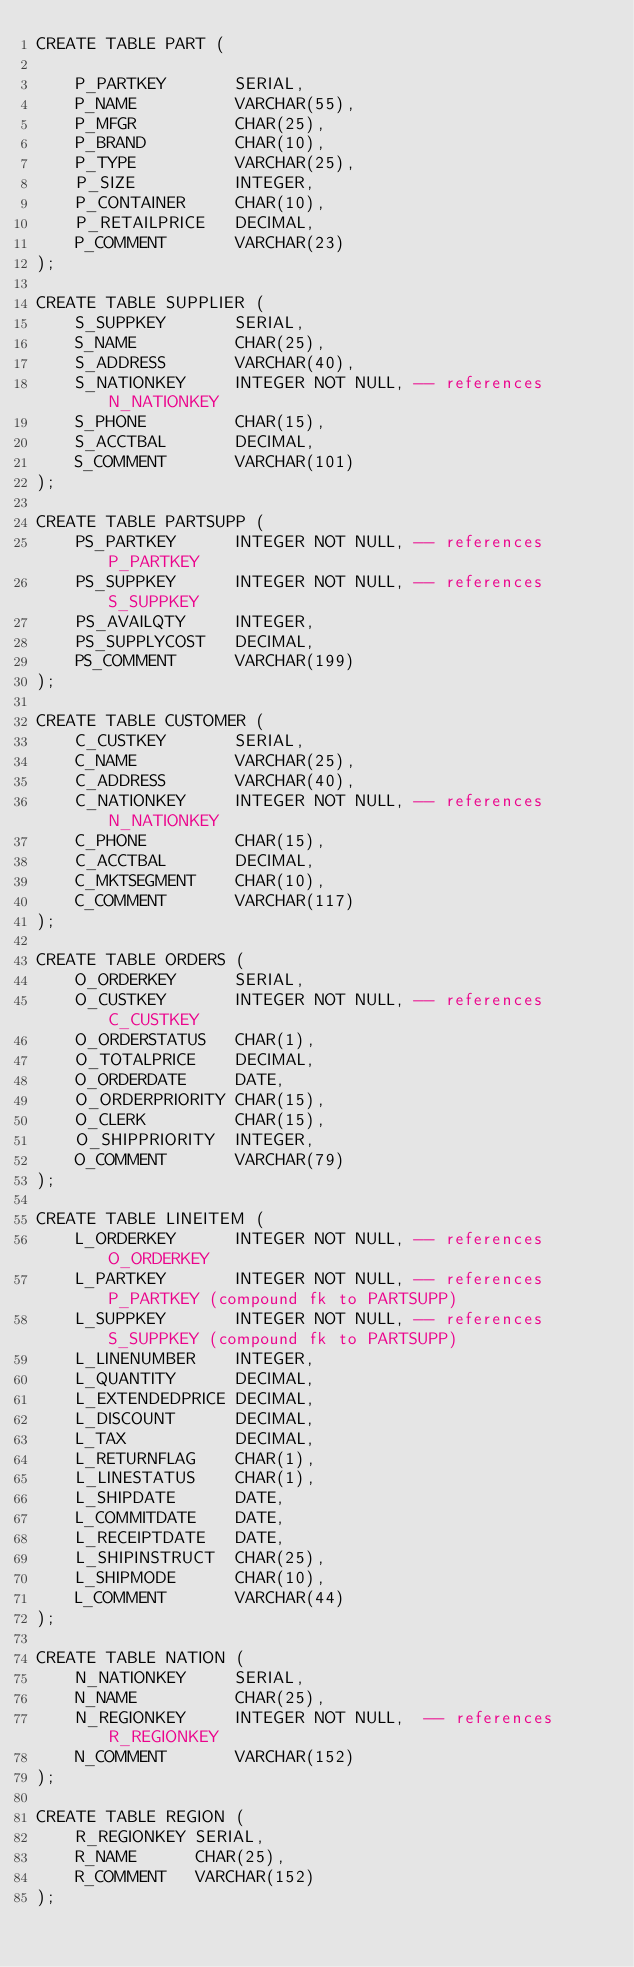Convert code to text. <code><loc_0><loc_0><loc_500><loc_500><_SQL_>CREATE TABLE PART (

	P_PARTKEY		SERIAL,
	P_NAME			VARCHAR(55),
	P_MFGR			CHAR(25),
	P_BRAND			CHAR(10),
	P_TYPE			VARCHAR(25),
	P_SIZE			INTEGER,
	P_CONTAINER		CHAR(10),
	P_RETAILPRICE	DECIMAL,
	P_COMMENT		VARCHAR(23)
);

CREATE TABLE SUPPLIER (
	S_SUPPKEY		SERIAL,
	S_NAME			CHAR(25),
	S_ADDRESS		VARCHAR(40),
	S_NATIONKEY		INTEGER NOT NULL, -- references N_NATIONKEY
	S_PHONE			CHAR(15),
	S_ACCTBAL		DECIMAL,
	S_COMMENT		VARCHAR(101)
);

CREATE TABLE PARTSUPP (
	PS_PARTKEY		INTEGER NOT NULL, -- references P_PARTKEY
	PS_SUPPKEY		INTEGER NOT NULL, -- references S_SUPPKEY
	PS_AVAILQTY		INTEGER,
	PS_SUPPLYCOST	DECIMAL,
	PS_COMMENT		VARCHAR(199)
);

CREATE TABLE CUSTOMER (
	C_CUSTKEY		SERIAL,
	C_NAME			VARCHAR(25),
	C_ADDRESS		VARCHAR(40),
	C_NATIONKEY		INTEGER NOT NULL, -- references N_NATIONKEY
	C_PHONE			CHAR(15),
	C_ACCTBAL		DECIMAL,
	C_MKTSEGMENT	CHAR(10),
	C_COMMENT		VARCHAR(117)
);

CREATE TABLE ORDERS (
	O_ORDERKEY		SERIAL,
	O_CUSTKEY		INTEGER NOT NULL, -- references C_CUSTKEY
	O_ORDERSTATUS	CHAR(1),
	O_TOTALPRICE	DECIMAL,
	O_ORDERDATE		DATE,
	O_ORDERPRIORITY	CHAR(15),
	O_CLERK			CHAR(15),
	O_SHIPPRIORITY	INTEGER,
	O_COMMENT		VARCHAR(79)
);

CREATE TABLE LINEITEM (
	L_ORDERKEY		INTEGER NOT NULL, -- references O_ORDERKEY
	L_PARTKEY		INTEGER NOT NULL, -- references P_PARTKEY (compound fk to PARTSUPP)
	L_SUPPKEY		INTEGER NOT NULL, -- references S_SUPPKEY (compound fk to PARTSUPP)
	L_LINENUMBER	INTEGER,
	L_QUANTITY		DECIMAL,
	L_EXTENDEDPRICE	DECIMAL,
	L_DISCOUNT		DECIMAL,
	L_TAX			DECIMAL,
	L_RETURNFLAG	CHAR(1),
	L_LINESTATUS	CHAR(1),
	L_SHIPDATE		DATE,
	L_COMMITDATE	DATE,
	L_RECEIPTDATE	DATE,
	L_SHIPINSTRUCT	CHAR(25),
	L_SHIPMODE		CHAR(10),
	L_COMMENT		VARCHAR(44)
);

CREATE TABLE NATION (
	N_NATIONKEY		SERIAL,
	N_NAME			CHAR(25),
	N_REGIONKEY		INTEGER NOT NULL,  -- references R_REGIONKEY
	N_COMMENT		VARCHAR(152)
);

CREATE TABLE REGION (
	R_REGIONKEY	SERIAL,
	R_NAME		CHAR(25),
	R_COMMENT	VARCHAR(152)
);
</code> 